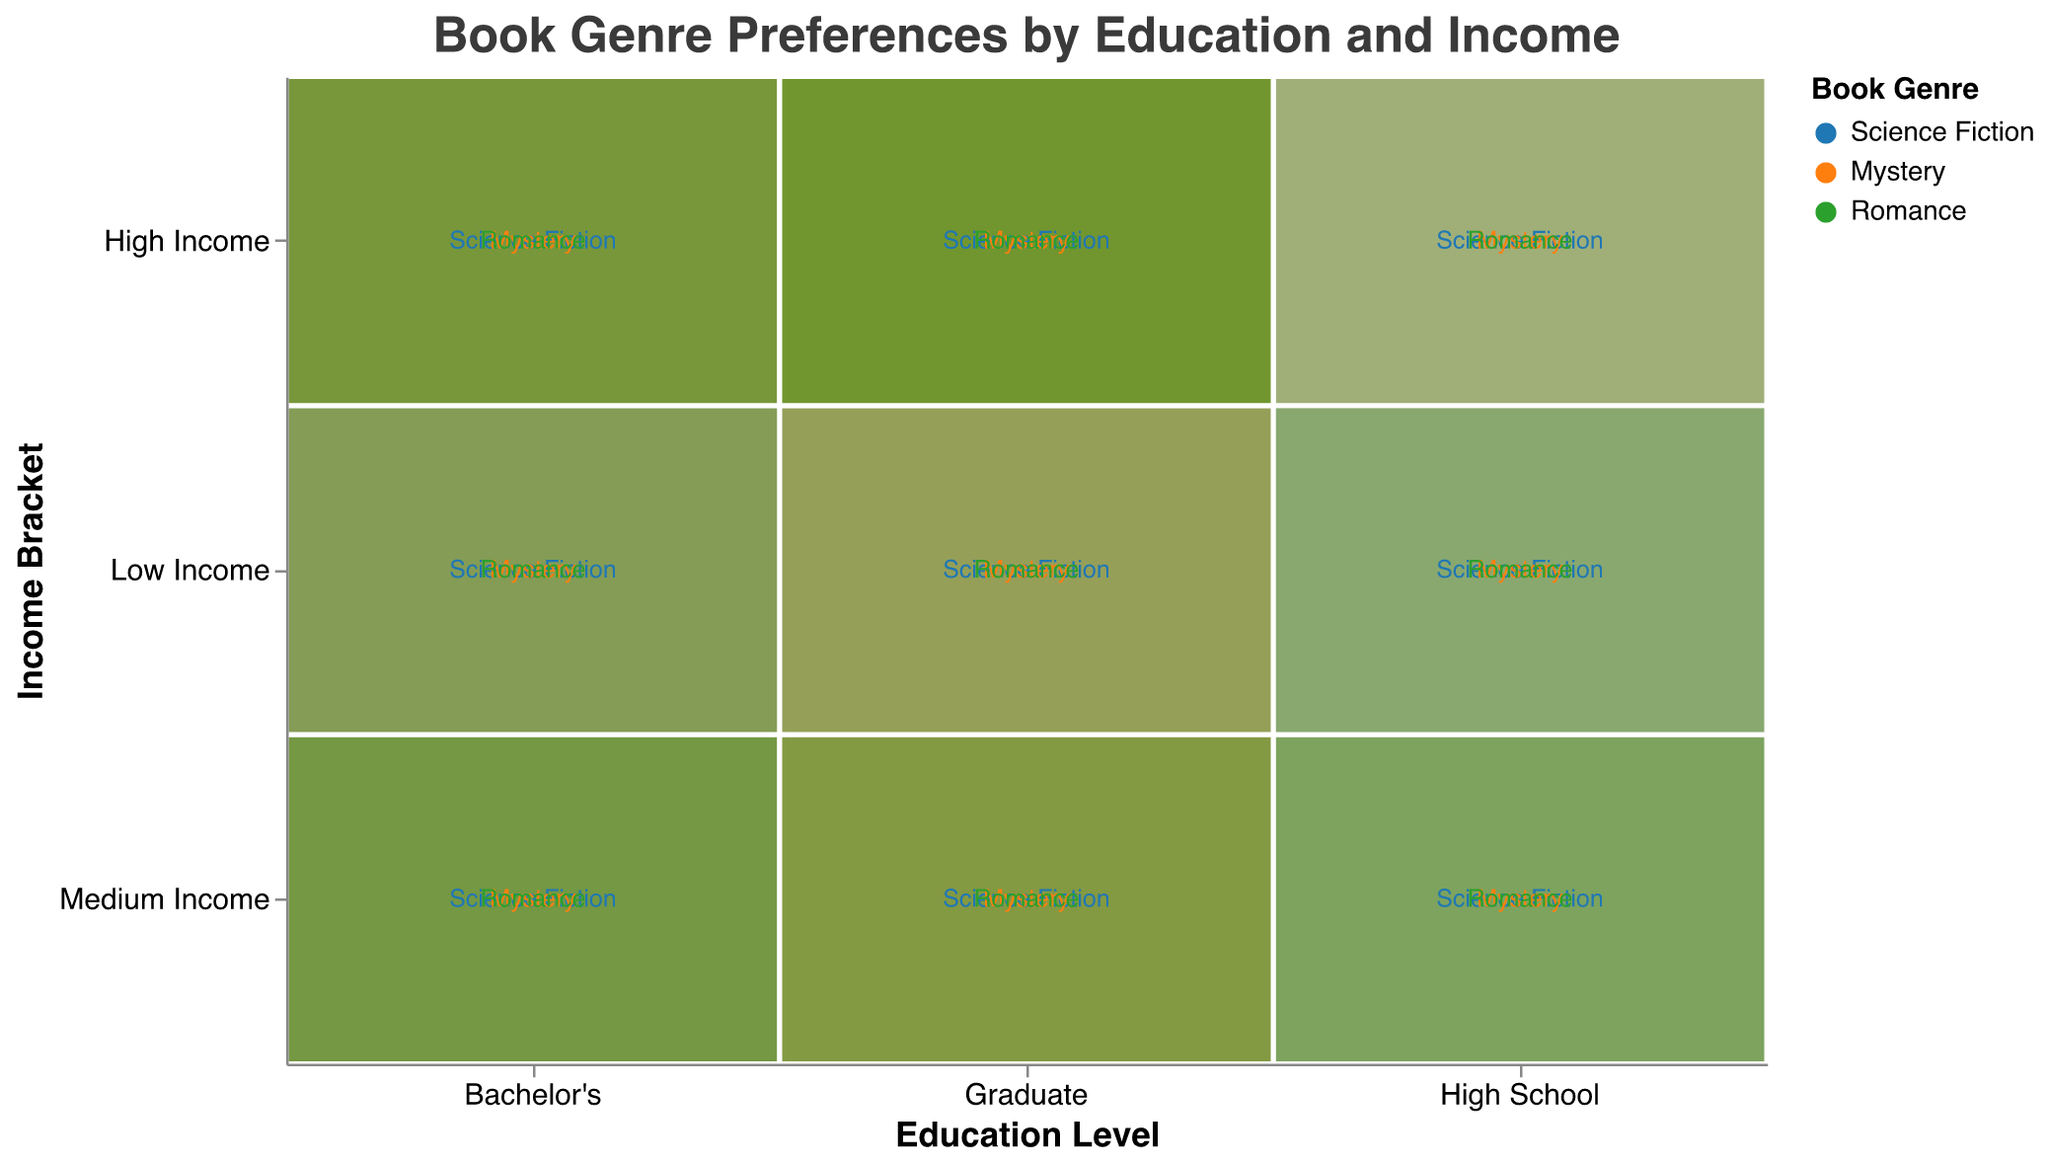What is the title of the mosaic plot? The title can be seen at the top of the mosaic plot, which provides an overview of the data displayed.
Answer: Book Genre Preferences by Education and Income How many education levels are shown in the plot? The x-axis of the plot represents the education levels. By counting the different categories along the x-axis, we can determine the number of education levels.
Answer: 3 Which book genre has the highest frequency for high school graduates with medium income? By looking at the intersecting section of 'High School' and 'Medium Income' and observing the color-coded genres, you can see which genre has the highest area. The highest frequency area will belong to the genre with the darkest shade.
Answer: Science Fiction For which education level and income bracket do graduate students have the highest preference for mystery novels? Refer to the 'Graduate' section along the x-axis and identify the income bracket where the 'Mystery' genre (orange color) segment is largest. The highest frequency area will belong to the genre with the darkest shade.
Answer: High Income Compare the frequency of Romance novels between Bachelor's degree holders with low income and graduate students with medium income. Which group prefers this genre more? Compare the 'Romance' genre (green color) segments in the relevant income brackets for 'Bachelor's' and 'Graduate'. The segment with a larger area represents the higher frequency.
Answer: Graduate students with medium income What can be said about the preference of mystery novels among different education levels irrespective of income? By summarizing the 'Mystery' genre segments across different education levels and ignoring income brackets, we can see which education level has the most area for Mystery novels.
Answer: Graduate students prefer them the most What is the least preferred book genre among high-income earners for bachelor's degree holders? Within the 'Bachelor's' section along the x-axis and 'High Income' income bracket, observe the genre with the smallest segment.
Answer: Romance Which income bracket for high school graduates has the highest total frequency for all book genres? By summing the frequencies (area) of all genres within each income bracket for high school graduates, the income bracket with the highest total area can be identified.
Answer: Medium Income How does the preference for science fiction novels change with income for graduate students? By observing the 'Science Fiction' genre (blue color) segments across different income levels within the 'Graduate' category, note how the area changes from 'Low Income' to 'High Income'. The area increases or decreases correspondingly.
Answer: Increases Compare the combined frequency of all book genres for low income and high-income brackets among graduates. Which group shows higher overall preferences for reading? Sum the frequencies (areas) of all genres for both 'Low Income' and 'High Income' within the 'Graduate' section, and the group with the larger total area indicates higher reading preferences.
Answer: High Income 